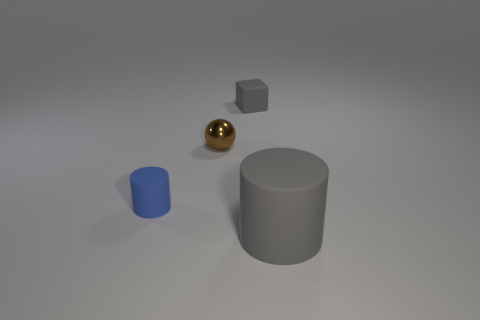Add 2 cubes. How many objects exist? 6 Subtract all spheres. How many objects are left? 3 Subtract all blue rubber things. Subtract all small red shiny balls. How many objects are left? 3 Add 3 blue matte objects. How many blue matte objects are left? 4 Add 2 cyan balls. How many cyan balls exist? 2 Subtract 0 purple cylinders. How many objects are left? 4 